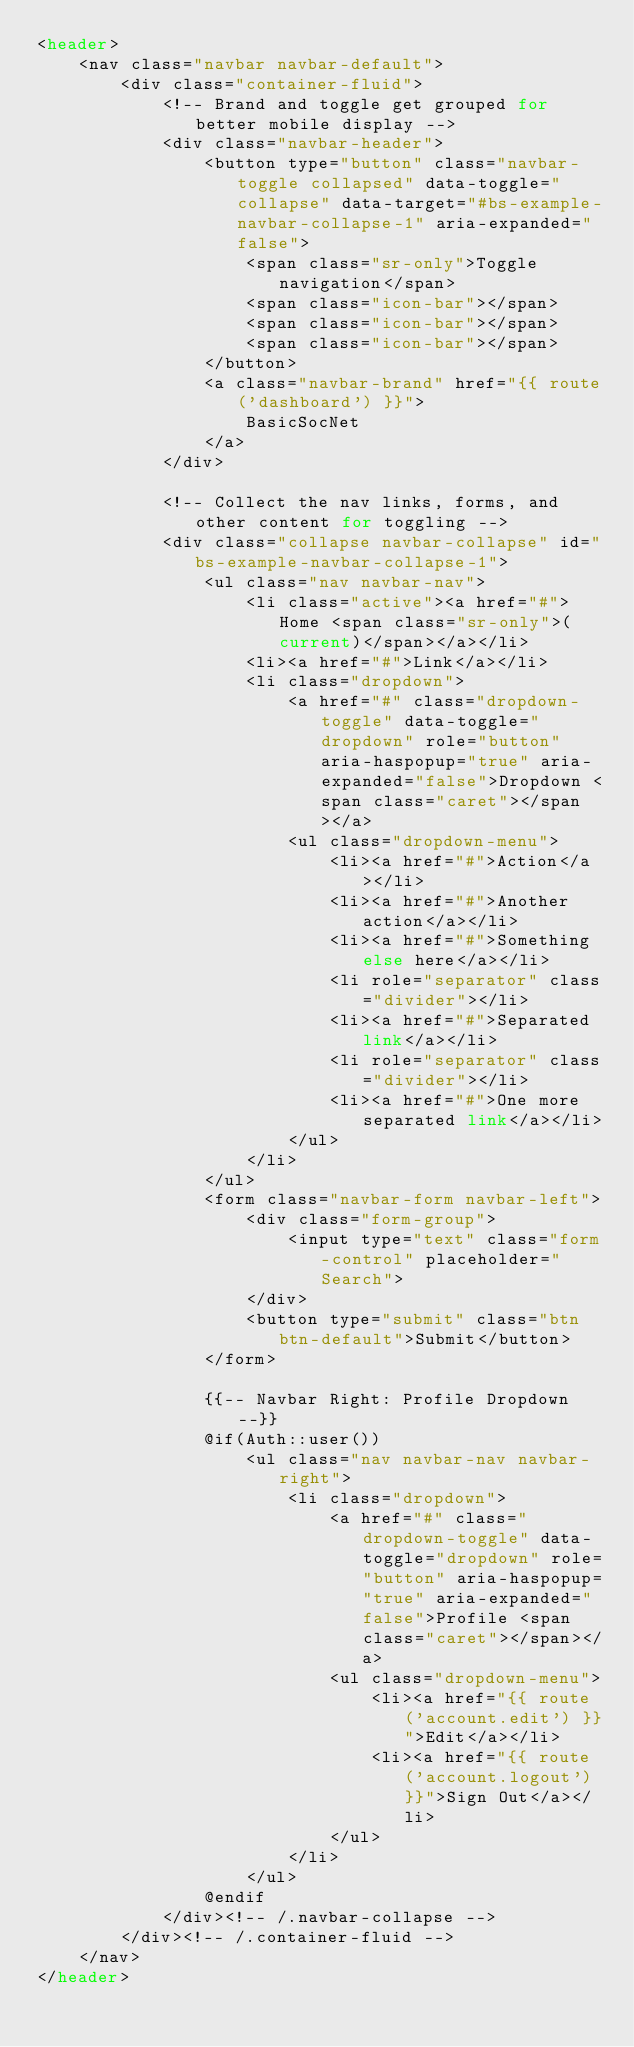<code> <loc_0><loc_0><loc_500><loc_500><_PHP_><header>
    <nav class="navbar navbar-default">
        <div class="container-fluid">
            <!-- Brand and toggle get grouped for better mobile display -->
            <div class="navbar-header">
                <button type="button" class="navbar-toggle collapsed" data-toggle="collapse" data-target="#bs-example-navbar-collapse-1" aria-expanded="false">
                    <span class="sr-only">Toggle navigation</span>
                    <span class="icon-bar"></span>
                    <span class="icon-bar"></span>
                    <span class="icon-bar"></span>
                </button>
                <a class="navbar-brand" href="{{ route('dashboard') }}">
                    BasicSocNet
                </a>
            </div>

            <!-- Collect the nav links, forms, and other content for toggling -->
            <div class="collapse navbar-collapse" id="bs-example-navbar-collapse-1">
                <ul class="nav navbar-nav">
                    <li class="active"><a href="#">Home <span class="sr-only">(current)</span></a></li>
                    <li><a href="#">Link</a></li>
                    <li class="dropdown">
                        <a href="#" class="dropdown-toggle" data-toggle="dropdown" role="button" aria-haspopup="true" aria-expanded="false">Dropdown <span class="caret"></span></a>
                        <ul class="dropdown-menu">
                            <li><a href="#">Action</a></li>
                            <li><a href="#">Another action</a></li>
                            <li><a href="#">Something else here</a></li>
                            <li role="separator" class="divider"></li>
                            <li><a href="#">Separated link</a></li>
                            <li role="separator" class="divider"></li>
                            <li><a href="#">One more separated link</a></li>
                        </ul>
                    </li>
                </ul>
                <form class="navbar-form navbar-left">
                    <div class="form-group">
                        <input type="text" class="form-control" placeholder="Search">
                    </div>
                    <button type="submit" class="btn btn-default">Submit</button>
                </form>

                {{-- Navbar Right: Profile Dropdown --}}
                @if(Auth::user())
                    <ul class="nav navbar-nav navbar-right">
                        <li class="dropdown">
                            <a href="#" class="dropdown-toggle" data-toggle="dropdown" role="button" aria-haspopup="true" aria-expanded="false">Profile <span class="caret"></span></a>
                            <ul class="dropdown-menu">
                                <li><a href="{{ route('account.edit') }}">Edit</a></li>
                                <li><a href="{{ route('account.logout') }}">Sign Out</a></li>
                            </ul>
                        </li>
                    </ul>
                @endif
            </div><!-- /.navbar-collapse -->
        </div><!-- /.container-fluid -->
    </nav>
</header>
</code> 